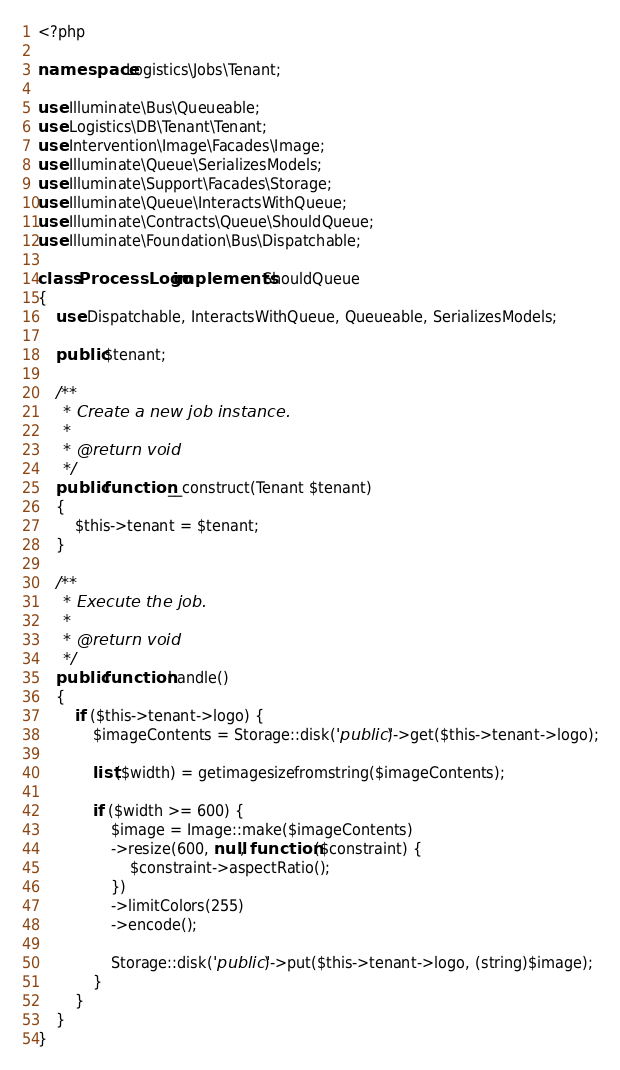Convert code to text. <code><loc_0><loc_0><loc_500><loc_500><_PHP_><?php

namespace Logistics\Jobs\Tenant;

use Illuminate\Bus\Queueable;
use Logistics\DB\Tenant\Tenant;
use Intervention\Image\Facades\Image;
use Illuminate\Queue\SerializesModels;
use Illuminate\Support\Facades\Storage;
use Illuminate\Queue\InteractsWithQueue;
use Illuminate\Contracts\Queue\ShouldQueue;
use Illuminate\Foundation\Bus\Dispatchable;

class ProcessLogo implements ShouldQueue
{
    use Dispatchable, InteractsWithQueue, Queueable, SerializesModels;

    public $tenant;

    /**
     * Create a new job instance.
     *
     * @return void
     */
    public function __construct(Tenant $tenant)
    {
        $this->tenant = $tenant;
    }

    /**
     * Execute the job.
     *
     * @return void
     */
    public function handle()
    {
        if ($this->tenant->logo) {
            $imageContents = Storage::disk('public')->get($this->tenant->logo);
            
            list($width) = getimagesizefromstring($imageContents);
            
            if ($width >= 600) {
                $image = Image::make($imageContents)
                ->resize(600, null, function ($constraint) {
                    $constraint->aspectRatio();
                })
                ->limitColors(255)
                ->encode();
                
                Storage::disk('public')->put($this->tenant->logo, (string)$image);
            }
        }
    }
}
</code> 